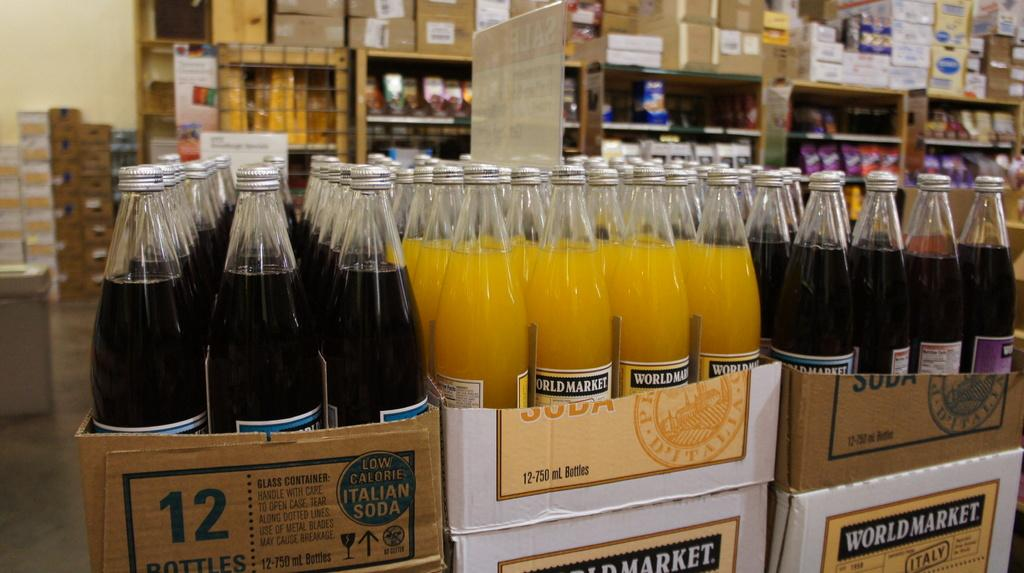Provide a one-sentence caption for the provided image. A display of beverages features World Market products. 